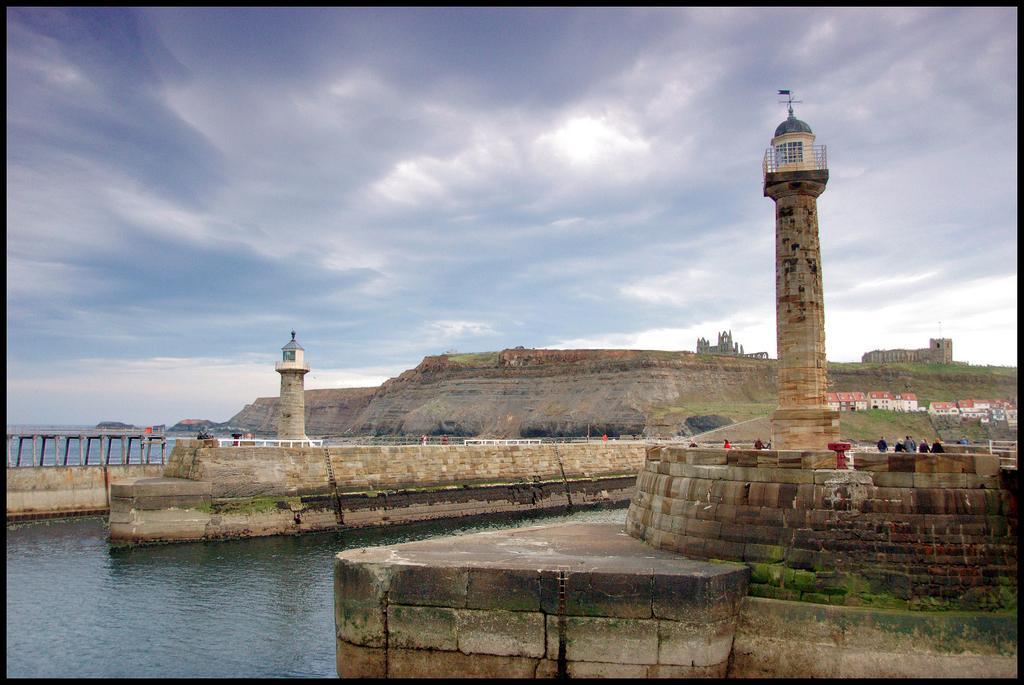Could you give a brief overview of what you see in this image? In this picture we can see water at the left bottom, on the left side there is a bridge, there are two towers in the middle, on the right side we can see some people, in the background there are some buildings and a fort, there is the sky and clouds at the top of the picture. 